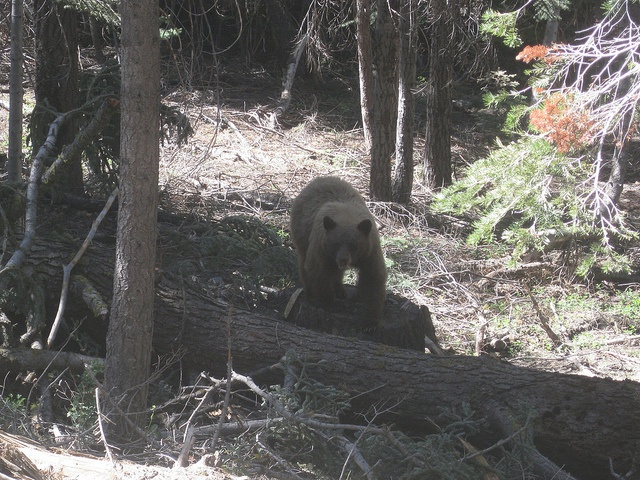Describe the objects in this image and their specific colors. I can see a bear in gray and black tones in this image. 